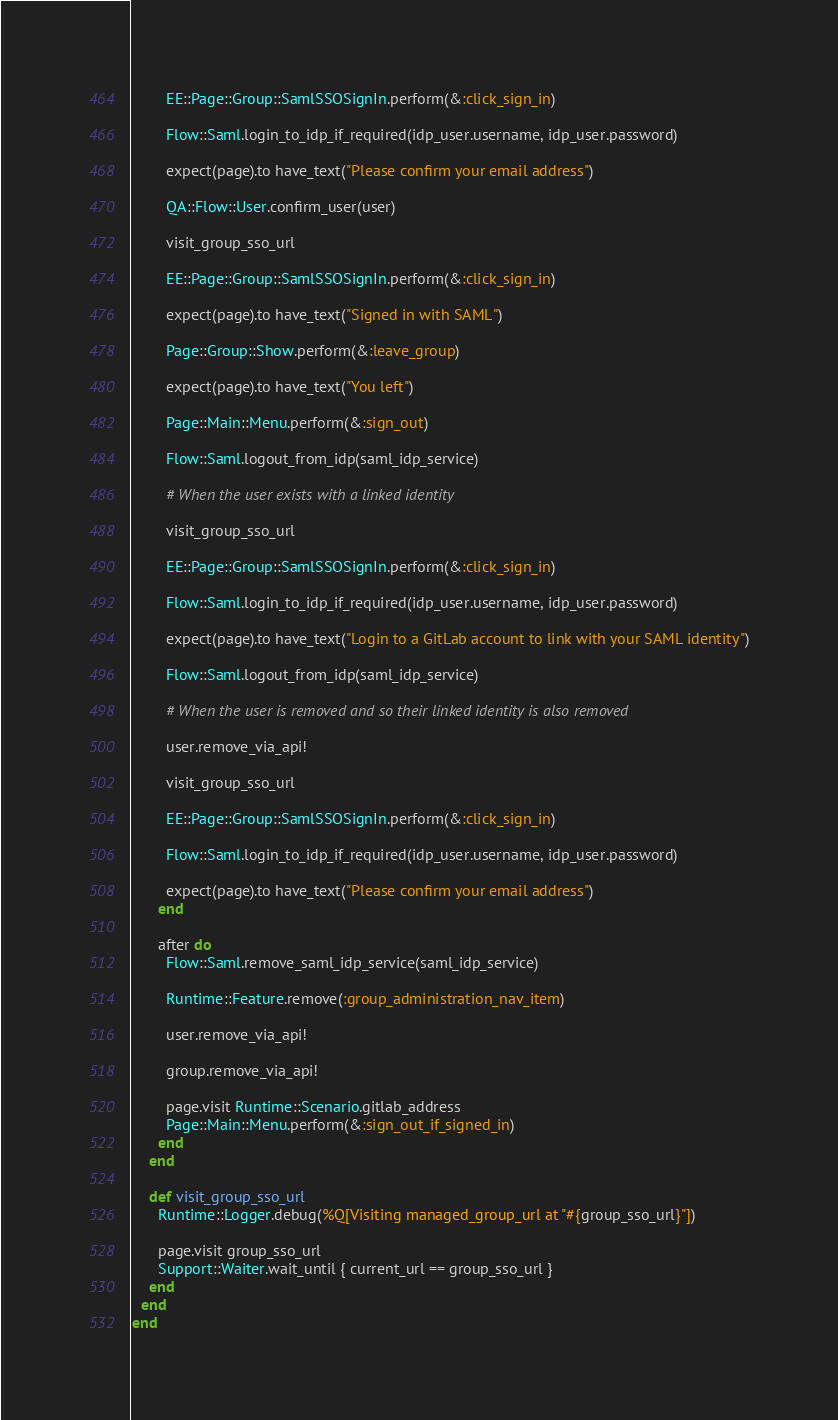Convert code to text. <code><loc_0><loc_0><loc_500><loc_500><_Ruby_>
        EE::Page::Group::SamlSSOSignIn.perform(&:click_sign_in)

        Flow::Saml.login_to_idp_if_required(idp_user.username, idp_user.password)

        expect(page).to have_text("Please confirm your email address")

        QA::Flow::User.confirm_user(user)

        visit_group_sso_url

        EE::Page::Group::SamlSSOSignIn.perform(&:click_sign_in)

        expect(page).to have_text("Signed in with SAML")

        Page::Group::Show.perform(&:leave_group)

        expect(page).to have_text("You left")

        Page::Main::Menu.perform(&:sign_out)

        Flow::Saml.logout_from_idp(saml_idp_service)

        # When the user exists with a linked identity

        visit_group_sso_url

        EE::Page::Group::SamlSSOSignIn.perform(&:click_sign_in)

        Flow::Saml.login_to_idp_if_required(idp_user.username, idp_user.password)

        expect(page).to have_text("Login to a GitLab account to link with your SAML identity")

        Flow::Saml.logout_from_idp(saml_idp_service)

        # When the user is removed and so their linked identity is also removed

        user.remove_via_api!

        visit_group_sso_url

        EE::Page::Group::SamlSSOSignIn.perform(&:click_sign_in)

        Flow::Saml.login_to_idp_if_required(idp_user.username, idp_user.password)

        expect(page).to have_text("Please confirm your email address")
      end

      after do
        Flow::Saml.remove_saml_idp_service(saml_idp_service)

        Runtime::Feature.remove(:group_administration_nav_item)

        user.remove_via_api!

        group.remove_via_api!

        page.visit Runtime::Scenario.gitlab_address
        Page::Main::Menu.perform(&:sign_out_if_signed_in)
      end
    end

    def visit_group_sso_url
      Runtime::Logger.debug(%Q[Visiting managed_group_url at "#{group_sso_url}"])

      page.visit group_sso_url
      Support::Waiter.wait_until { current_url == group_sso_url }
    end
  end
end
</code> 